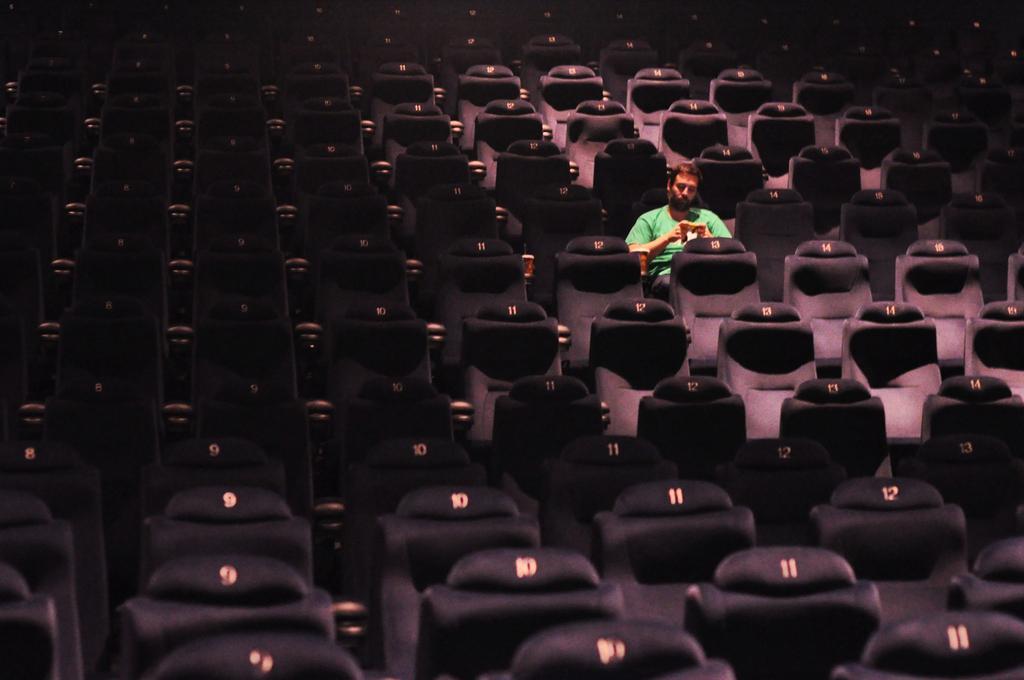Describe this image in one or two sentences. This picture might be taken in a theater in this image there are a group of chairs, and there is one person who is sitting and he is wearing a green t-shirt and he is holding something. 